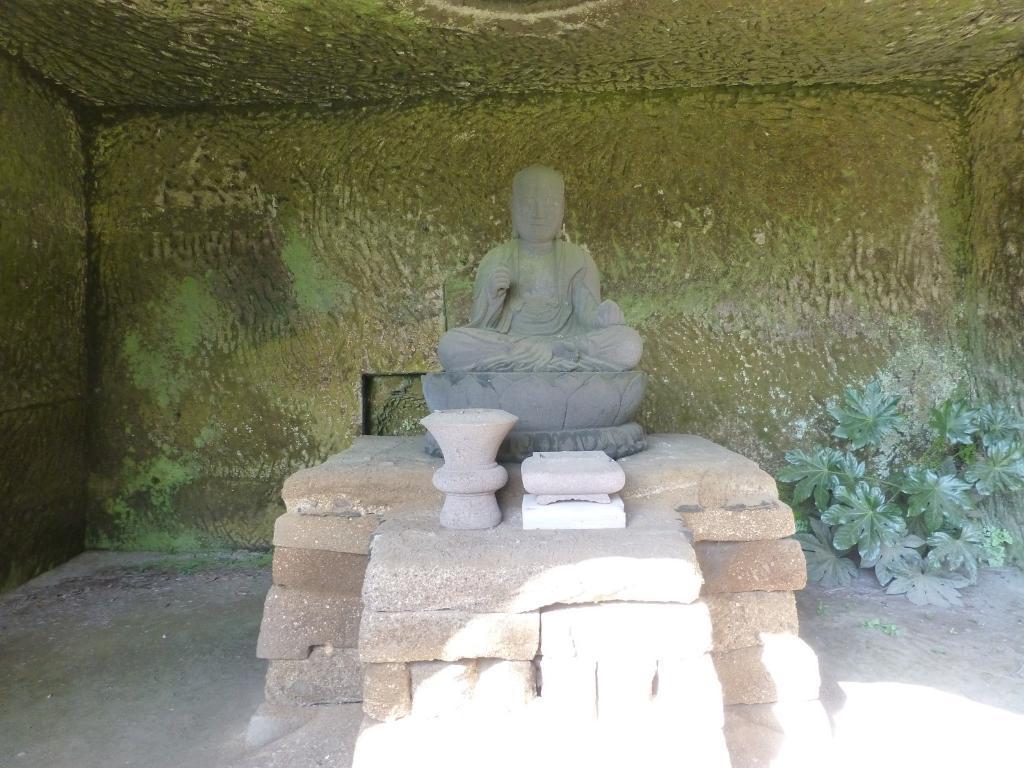In one or two sentences, can you explain what this image depicts? In this image I can see a statute which is in grey color. I can see a brick wall. Background is in green color and I can see a small plant. 